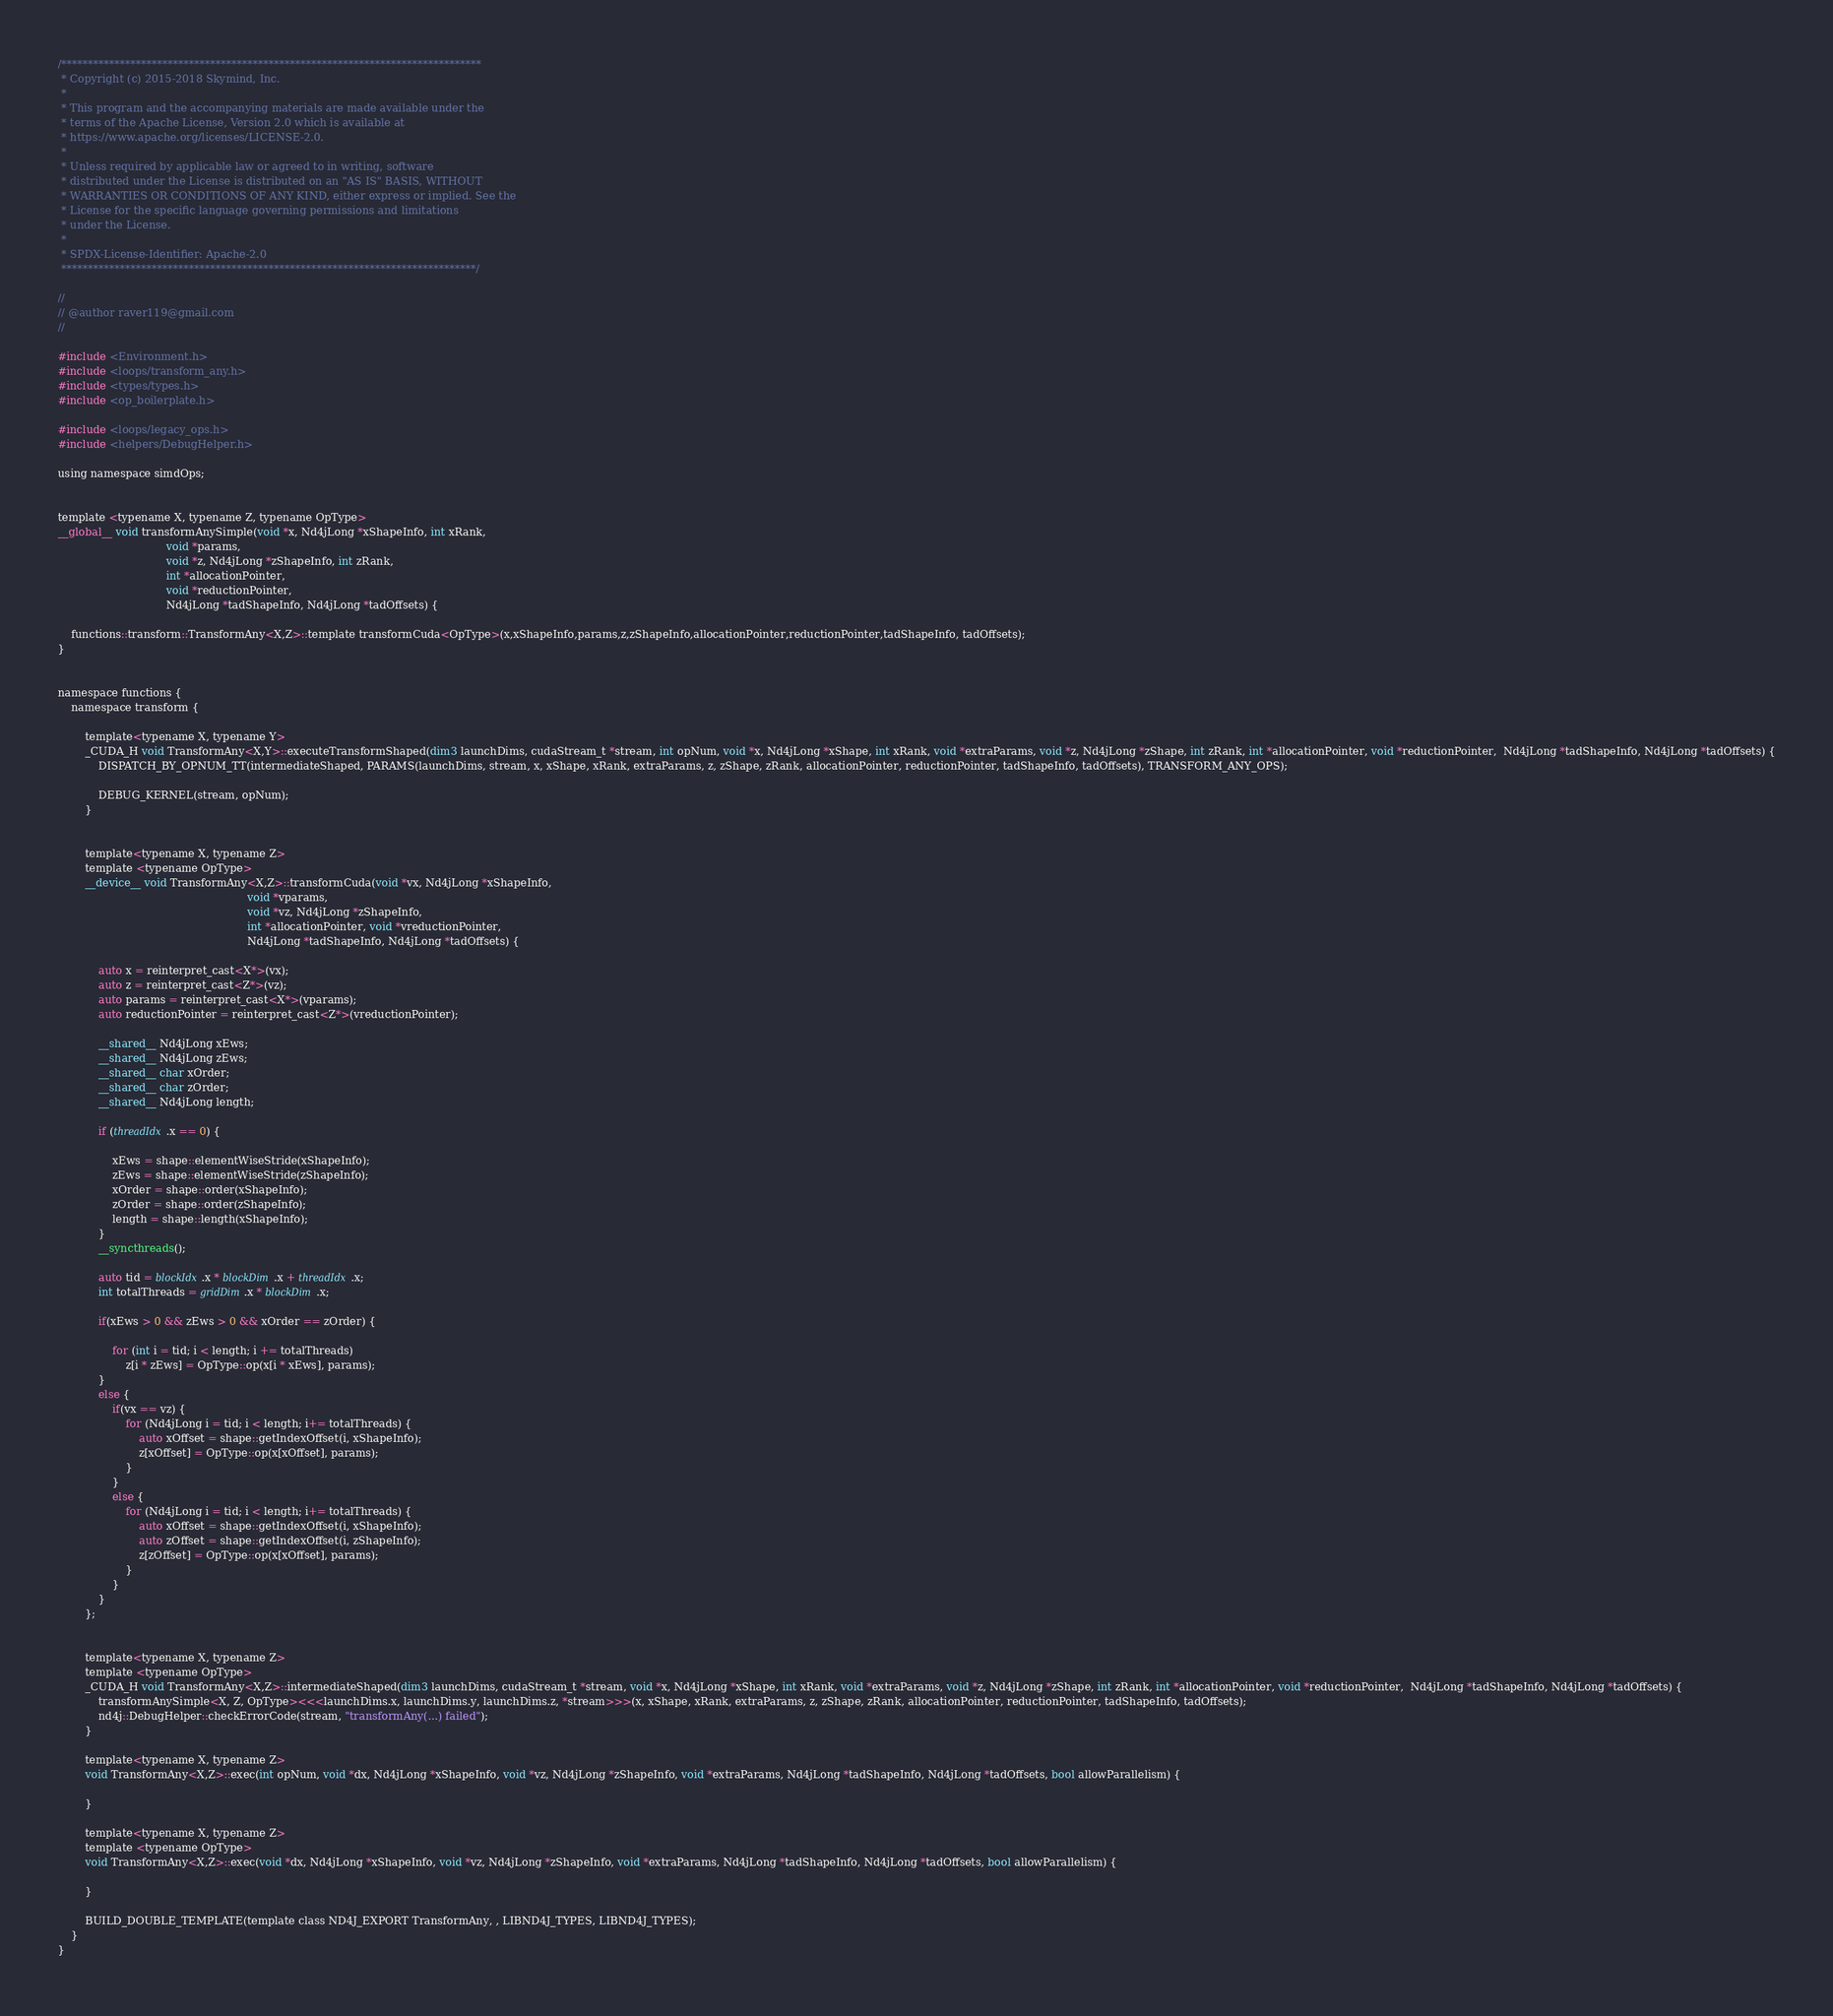<code> <loc_0><loc_0><loc_500><loc_500><_Cuda_>/*******************************************************************************
 * Copyright (c) 2015-2018 Skymind, Inc.
 *
 * This program and the accompanying materials are made available under the
 * terms of the Apache License, Version 2.0 which is available at
 * https://www.apache.org/licenses/LICENSE-2.0.
 *
 * Unless required by applicable law or agreed to in writing, software
 * distributed under the License is distributed on an "AS IS" BASIS, WITHOUT
 * WARRANTIES OR CONDITIONS OF ANY KIND, either express or implied. See the
 * License for the specific language governing permissions and limitations
 * under the License.
 *
 * SPDX-License-Identifier: Apache-2.0
 ******************************************************************************/

//
// @author raver119@gmail.com
//

#include <Environment.h>
#include <loops/transform_any.h>
#include <types/types.h>
#include <op_boilerplate.h>

#include <loops/legacy_ops.h>
#include <helpers/DebugHelper.h>

using namespace simdOps;


template <typename X, typename Z, typename OpType>
__global__ void transformAnySimple(void *x, Nd4jLong *xShapeInfo, int xRank,
								void *params,
								void *z, Nd4jLong *zShapeInfo, int zRank,
								int *allocationPointer,
								void *reductionPointer,
								Nd4jLong *tadShapeInfo, Nd4jLong *tadOffsets) {

	functions::transform::TransformAny<X,Z>::template transformCuda<OpType>(x,xShapeInfo,params,z,zShapeInfo,allocationPointer,reductionPointer,tadShapeInfo, tadOffsets);
}


namespace functions {
    namespace transform {

        template<typename X, typename Y>
        _CUDA_H void TransformAny<X,Y>::executeTransformShaped(dim3 launchDims, cudaStream_t *stream, int opNum, void *x, Nd4jLong *xShape, int xRank, void *extraParams, void *z, Nd4jLong *zShape, int zRank, int *allocationPointer, void *reductionPointer,  Nd4jLong *tadShapeInfo, Nd4jLong *tadOffsets) {
			DISPATCH_BY_OPNUM_TT(intermediateShaped, PARAMS(launchDims, stream, x, xShape, xRank, extraParams, z, zShape, zRank, allocationPointer, reductionPointer, tadShapeInfo, tadOffsets), TRANSFORM_ANY_OPS);

            DEBUG_KERNEL(stream, opNum);
        }


        template<typename X, typename Z>
        template <typename OpType>
        __device__ void TransformAny<X,Z>::transformCuda(void *vx, Nd4jLong *xShapeInfo,
        												void *vparams,
        												void *vz, Nd4jLong *zShapeInfo,
        												int *allocationPointer, void *vreductionPointer,
        												Nd4jLong *tadShapeInfo, Nd4jLong *tadOffsets) {

        	auto x = reinterpret_cast<X*>(vx);
		    auto z = reinterpret_cast<Z*>(vz);
		    auto params = reinterpret_cast<X*>(vparams);
		    auto reductionPointer = reinterpret_cast<Z*>(vreductionPointer);

		    __shared__ Nd4jLong xEws;
    	    __shared__ Nd4jLong zEws;
        	__shared__ char xOrder;
            __shared__ char zOrder;
            __shared__ Nd4jLong length;

	        if (threadIdx.x == 0) {

        		xEws = shape::elementWiseStride(xShapeInfo);
            	zEws = shape::elementWiseStride(zShapeInfo);
                xOrder = shape::order(xShapeInfo);
				zOrder = shape::order(zShapeInfo);
				length = shape::length(xShapeInfo);
            }
            __syncthreads();

	    	auto tid = blockIdx.x * blockDim.x + threadIdx.x;
			int totalThreads = gridDim.x * blockDim.x;

		    if(xEws > 0 && zEws > 0 && xOrder == zOrder) {

				for (int i = tid; i < length; i += totalThreads)
					z[i * zEws] = OpType::op(x[i * xEws], params);
		    }
		    else {
				if(vx == vz) {
					for (Nd4jLong i = tid; i < length; i+= totalThreads) {
						auto xOffset = shape::getIndexOffset(i, xShapeInfo);
	    		    	z[xOffset] = OpType::op(x[xOffset], params);
		    	   	}
				}
				else {
		    	   	for (Nd4jLong i = tid; i < length; i+= totalThreads) {
						auto xOffset = shape::getIndexOffset(i, xShapeInfo);
						auto zOffset = shape::getIndexOffset(i, zShapeInfo);
	    		    	z[zOffset] = OpType::op(x[xOffset], params);
		    	   	}
		    	}
		    }
	    };


		template<typename X, typename Z>
		template <typename OpType>
		_CUDA_H void TransformAny<X,Z>::intermediateShaped(dim3 launchDims, cudaStream_t *stream, void *x, Nd4jLong *xShape, int xRank, void *extraParams, void *z, Nd4jLong *zShape, int zRank, int *allocationPointer, void *reductionPointer,  Nd4jLong *tadShapeInfo, Nd4jLong *tadOffsets) {
			transformAnySimple<X, Z, OpType><<<launchDims.x, launchDims.y, launchDims.z, *stream>>>(x, xShape, xRank, extraParams, z, zShape, zRank, allocationPointer, reductionPointer, tadShapeInfo, tadOffsets);
            nd4j::DebugHelper::checkErrorCode(stream, "transformAny(...) failed");
		}

        template<typename X, typename Z>
        void TransformAny<X,Z>::exec(int opNum, void *dx, Nd4jLong *xShapeInfo, void *vz, Nd4jLong *zShapeInfo, void *extraParams, Nd4jLong *tadShapeInfo, Nd4jLong *tadOffsets, bool allowParallelism) {

        }

        template<typename X, typename Z>
        template <typename OpType>
        void TransformAny<X,Z>::exec(void *dx, Nd4jLong *xShapeInfo, void *vz, Nd4jLong *zShapeInfo, void *extraParams, Nd4jLong *tadShapeInfo, Nd4jLong *tadOffsets, bool allowParallelism) {

        }

        BUILD_DOUBLE_TEMPLATE(template class ND4J_EXPORT TransformAny, , LIBND4J_TYPES, LIBND4J_TYPES);
    }
}
</code> 